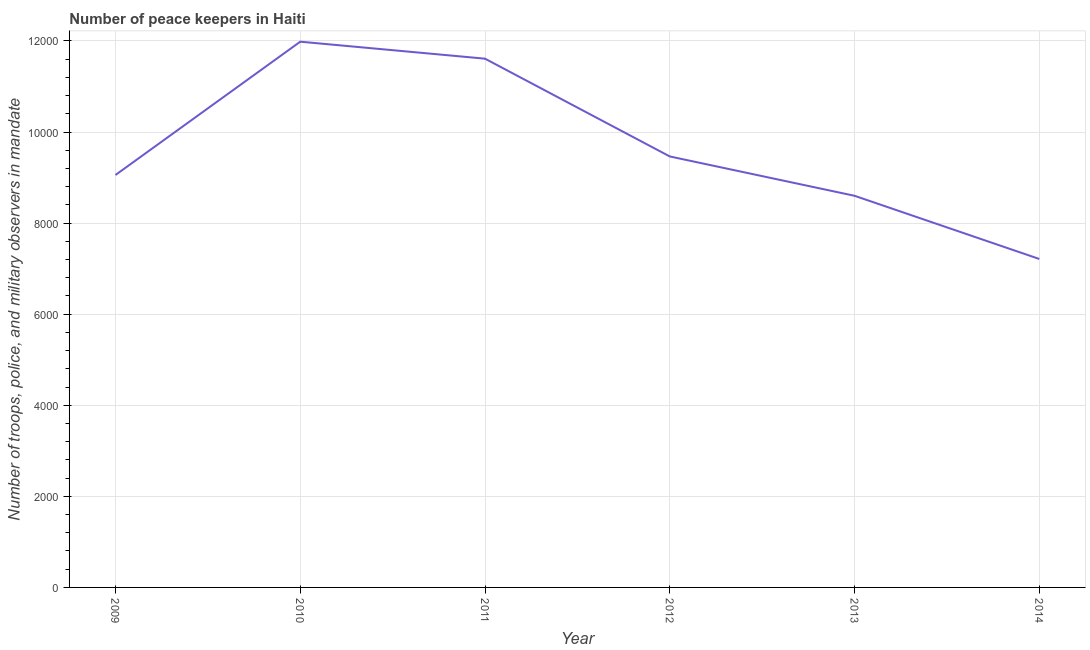What is the number of peace keepers in 2013?
Your answer should be very brief. 8600. Across all years, what is the maximum number of peace keepers?
Give a very brief answer. 1.20e+04. Across all years, what is the minimum number of peace keepers?
Make the answer very short. 7213. In which year was the number of peace keepers maximum?
Your answer should be very brief. 2010. In which year was the number of peace keepers minimum?
Your answer should be very brief. 2014. What is the sum of the number of peace keepers?
Your answer should be very brief. 5.79e+04. What is the difference between the number of peace keepers in 2009 and 2010?
Your answer should be compact. -2927. What is the average number of peace keepers per year?
Your answer should be compact. 9654.83. What is the median number of peace keepers?
Give a very brief answer. 9260.5. What is the ratio of the number of peace keepers in 2013 to that in 2014?
Keep it short and to the point. 1.19. What is the difference between the highest and the second highest number of peace keepers?
Your answer should be compact. 373. Is the sum of the number of peace keepers in 2013 and 2014 greater than the maximum number of peace keepers across all years?
Offer a very short reply. Yes. What is the difference between the highest and the lowest number of peace keepers?
Ensure brevity in your answer.  4771. Does the number of peace keepers monotonically increase over the years?
Offer a very short reply. No. Are the values on the major ticks of Y-axis written in scientific E-notation?
Offer a very short reply. No. Does the graph contain any zero values?
Your answer should be compact. No. Does the graph contain grids?
Your response must be concise. Yes. What is the title of the graph?
Your response must be concise. Number of peace keepers in Haiti. What is the label or title of the X-axis?
Make the answer very short. Year. What is the label or title of the Y-axis?
Offer a terse response. Number of troops, police, and military observers in mandate. What is the Number of troops, police, and military observers in mandate of 2009?
Ensure brevity in your answer.  9057. What is the Number of troops, police, and military observers in mandate of 2010?
Provide a succinct answer. 1.20e+04. What is the Number of troops, police, and military observers in mandate of 2011?
Provide a succinct answer. 1.16e+04. What is the Number of troops, police, and military observers in mandate of 2012?
Your response must be concise. 9464. What is the Number of troops, police, and military observers in mandate in 2013?
Provide a succinct answer. 8600. What is the Number of troops, police, and military observers in mandate in 2014?
Give a very brief answer. 7213. What is the difference between the Number of troops, police, and military observers in mandate in 2009 and 2010?
Make the answer very short. -2927. What is the difference between the Number of troops, police, and military observers in mandate in 2009 and 2011?
Your answer should be compact. -2554. What is the difference between the Number of troops, police, and military observers in mandate in 2009 and 2012?
Offer a terse response. -407. What is the difference between the Number of troops, police, and military observers in mandate in 2009 and 2013?
Your response must be concise. 457. What is the difference between the Number of troops, police, and military observers in mandate in 2009 and 2014?
Your response must be concise. 1844. What is the difference between the Number of troops, police, and military observers in mandate in 2010 and 2011?
Your answer should be very brief. 373. What is the difference between the Number of troops, police, and military observers in mandate in 2010 and 2012?
Make the answer very short. 2520. What is the difference between the Number of troops, police, and military observers in mandate in 2010 and 2013?
Your answer should be very brief. 3384. What is the difference between the Number of troops, police, and military observers in mandate in 2010 and 2014?
Provide a short and direct response. 4771. What is the difference between the Number of troops, police, and military observers in mandate in 2011 and 2012?
Make the answer very short. 2147. What is the difference between the Number of troops, police, and military observers in mandate in 2011 and 2013?
Offer a very short reply. 3011. What is the difference between the Number of troops, police, and military observers in mandate in 2011 and 2014?
Your answer should be very brief. 4398. What is the difference between the Number of troops, police, and military observers in mandate in 2012 and 2013?
Offer a very short reply. 864. What is the difference between the Number of troops, police, and military observers in mandate in 2012 and 2014?
Your answer should be very brief. 2251. What is the difference between the Number of troops, police, and military observers in mandate in 2013 and 2014?
Offer a very short reply. 1387. What is the ratio of the Number of troops, police, and military observers in mandate in 2009 to that in 2010?
Provide a short and direct response. 0.76. What is the ratio of the Number of troops, police, and military observers in mandate in 2009 to that in 2011?
Give a very brief answer. 0.78. What is the ratio of the Number of troops, police, and military observers in mandate in 2009 to that in 2012?
Ensure brevity in your answer.  0.96. What is the ratio of the Number of troops, police, and military observers in mandate in 2009 to that in 2013?
Offer a very short reply. 1.05. What is the ratio of the Number of troops, police, and military observers in mandate in 2009 to that in 2014?
Your response must be concise. 1.26. What is the ratio of the Number of troops, police, and military observers in mandate in 2010 to that in 2011?
Your answer should be very brief. 1.03. What is the ratio of the Number of troops, police, and military observers in mandate in 2010 to that in 2012?
Offer a very short reply. 1.27. What is the ratio of the Number of troops, police, and military observers in mandate in 2010 to that in 2013?
Give a very brief answer. 1.39. What is the ratio of the Number of troops, police, and military observers in mandate in 2010 to that in 2014?
Ensure brevity in your answer.  1.66. What is the ratio of the Number of troops, police, and military observers in mandate in 2011 to that in 2012?
Ensure brevity in your answer.  1.23. What is the ratio of the Number of troops, police, and military observers in mandate in 2011 to that in 2013?
Offer a terse response. 1.35. What is the ratio of the Number of troops, police, and military observers in mandate in 2011 to that in 2014?
Ensure brevity in your answer.  1.61. What is the ratio of the Number of troops, police, and military observers in mandate in 2012 to that in 2013?
Offer a very short reply. 1.1. What is the ratio of the Number of troops, police, and military observers in mandate in 2012 to that in 2014?
Offer a very short reply. 1.31. What is the ratio of the Number of troops, police, and military observers in mandate in 2013 to that in 2014?
Provide a succinct answer. 1.19. 